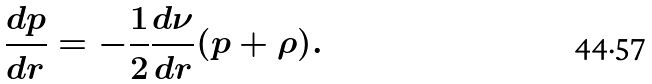Convert formula to latex. <formula><loc_0><loc_0><loc_500><loc_500>\frac { d p } { d r } = - \frac { 1 } { 2 } \frac { d \nu } { d r } ( p + \rho ) .</formula> 